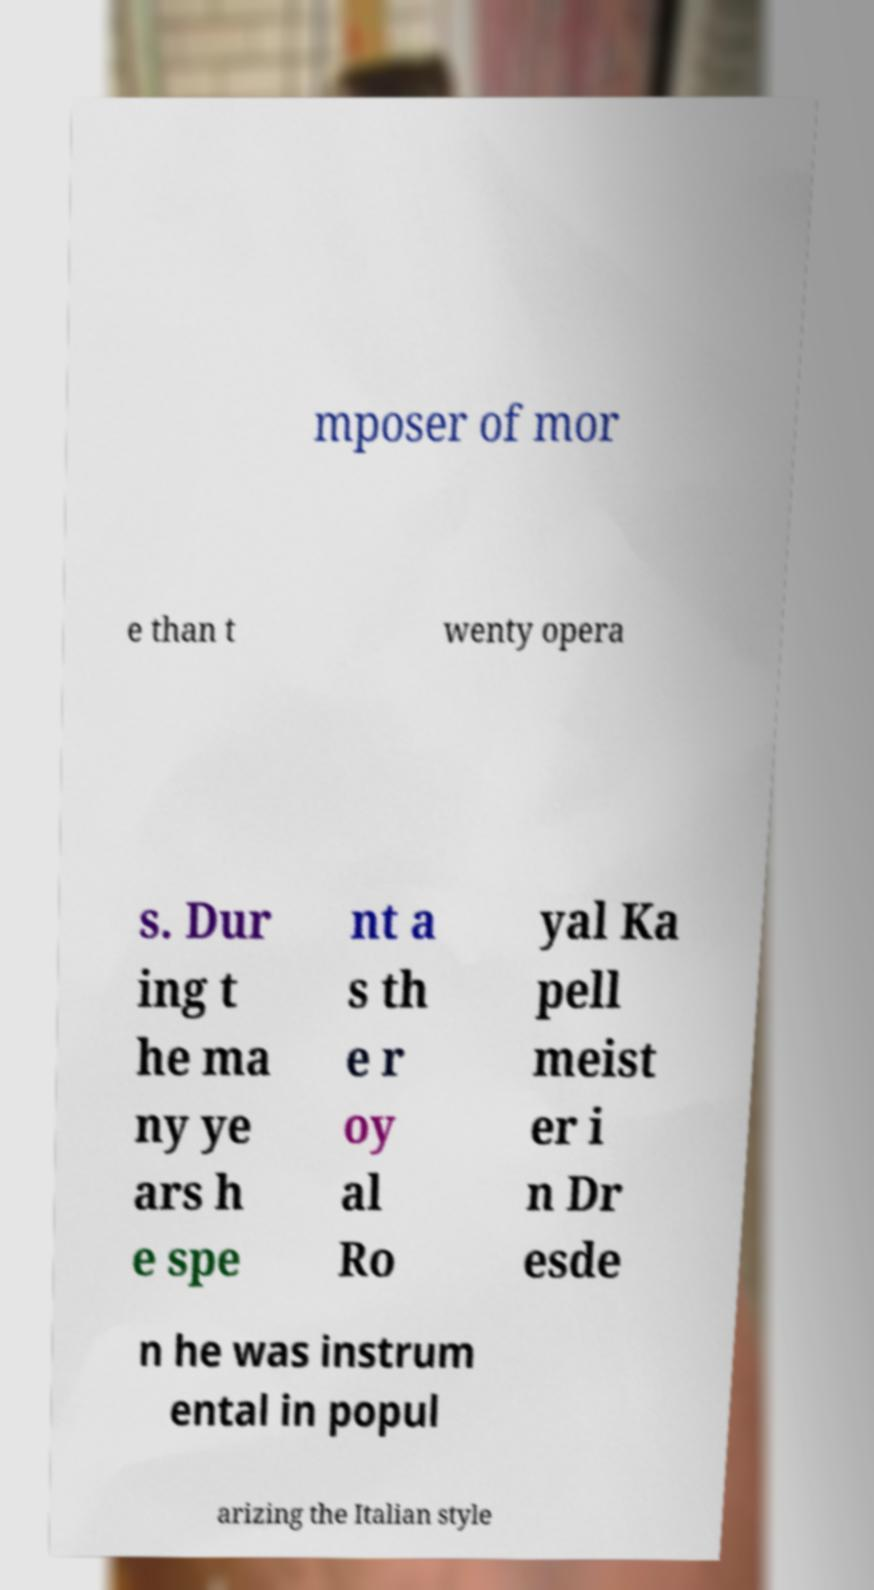What messages or text are displayed in this image? I need them in a readable, typed format. mposer of mor e than t wenty opera s. Dur ing t he ma ny ye ars h e spe nt a s th e r oy al Ro yal Ka pell meist er i n Dr esde n he was instrum ental in popul arizing the Italian style 